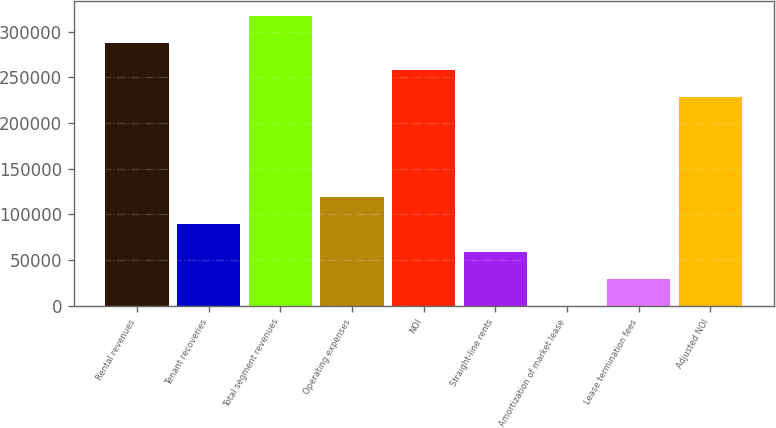<chart> <loc_0><loc_0><loc_500><loc_500><bar_chart><fcel>Rental revenues<fcel>Tenant recoveries<fcel>Total segment revenues<fcel>Operating expenses<fcel>NOI<fcel>Straight-line rents<fcel>Amortization of market lease<fcel>Lease termination fees<fcel>Adjusted NOI<nl><fcel>287832<fcel>89128.8<fcel>317511<fcel>118807<fcel>258154<fcel>59450.2<fcel>93<fcel>29771.6<fcel>228475<nl></chart> 